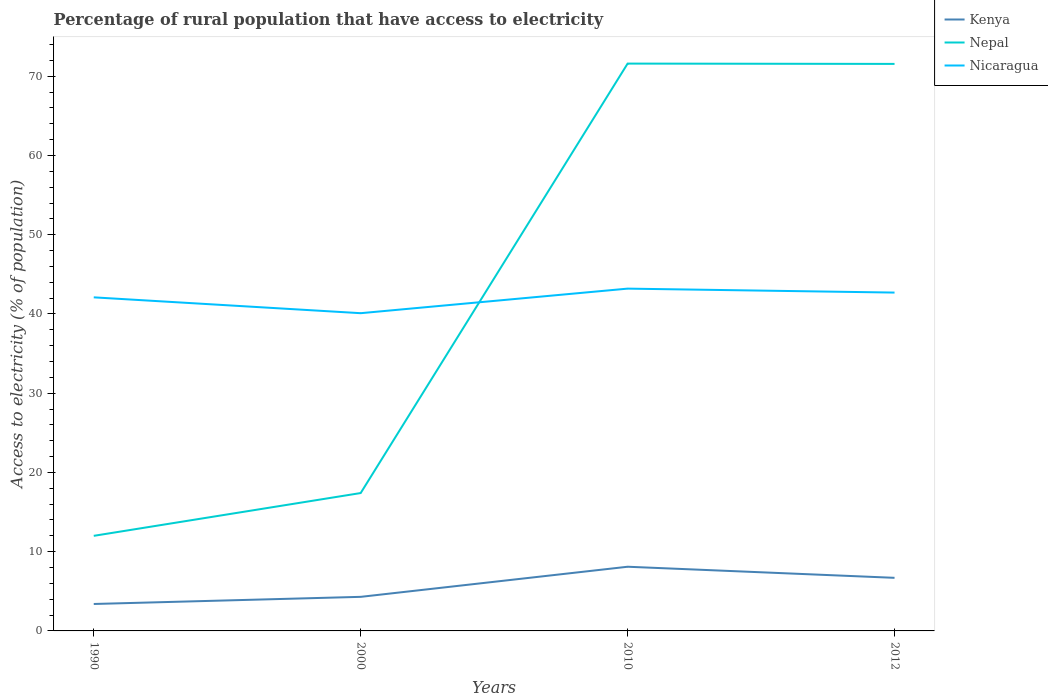Is the number of lines equal to the number of legend labels?
Offer a terse response. Yes. What is the total percentage of rural population that have access to electricity in Nicaragua in the graph?
Ensure brevity in your answer.  -1.1. What is the difference between the highest and the second highest percentage of rural population that have access to electricity in Kenya?
Offer a very short reply. 4.7. Are the values on the major ticks of Y-axis written in scientific E-notation?
Ensure brevity in your answer.  No. Does the graph contain any zero values?
Keep it short and to the point. No. Where does the legend appear in the graph?
Make the answer very short. Top right. What is the title of the graph?
Offer a terse response. Percentage of rural population that have access to electricity. What is the label or title of the Y-axis?
Your answer should be very brief. Access to electricity (% of population). What is the Access to electricity (% of population) of Kenya in 1990?
Your response must be concise. 3.4. What is the Access to electricity (% of population) in Nepal in 1990?
Your response must be concise. 12. What is the Access to electricity (% of population) of Nicaragua in 1990?
Keep it short and to the point. 42.1. What is the Access to electricity (% of population) in Nicaragua in 2000?
Make the answer very short. 40.1. What is the Access to electricity (% of population) of Kenya in 2010?
Your answer should be very brief. 8.1. What is the Access to electricity (% of population) in Nepal in 2010?
Give a very brief answer. 71.6. What is the Access to electricity (% of population) of Nicaragua in 2010?
Ensure brevity in your answer.  43.2. What is the Access to electricity (% of population) of Kenya in 2012?
Give a very brief answer. 6.7. What is the Access to electricity (% of population) of Nepal in 2012?
Ensure brevity in your answer.  71.56. What is the Access to electricity (% of population) of Nicaragua in 2012?
Ensure brevity in your answer.  42.7. Across all years, what is the maximum Access to electricity (% of population) in Kenya?
Offer a very short reply. 8.1. Across all years, what is the maximum Access to electricity (% of population) of Nepal?
Give a very brief answer. 71.6. Across all years, what is the maximum Access to electricity (% of population) in Nicaragua?
Offer a terse response. 43.2. Across all years, what is the minimum Access to electricity (% of population) in Kenya?
Keep it short and to the point. 3.4. Across all years, what is the minimum Access to electricity (% of population) of Nepal?
Make the answer very short. 12. Across all years, what is the minimum Access to electricity (% of population) in Nicaragua?
Ensure brevity in your answer.  40.1. What is the total Access to electricity (% of population) in Nepal in the graph?
Give a very brief answer. 172.56. What is the total Access to electricity (% of population) in Nicaragua in the graph?
Your response must be concise. 168.1. What is the difference between the Access to electricity (% of population) in Nepal in 1990 and that in 2000?
Offer a very short reply. -5.4. What is the difference between the Access to electricity (% of population) of Nicaragua in 1990 and that in 2000?
Your response must be concise. 2. What is the difference between the Access to electricity (% of population) in Kenya in 1990 and that in 2010?
Provide a succinct answer. -4.7. What is the difference between the Access to electricity (% of population) of Nepal in 1990 and that in 2010?
Offer a terse response. -59.6. What is the difference between the Access to electricity (% of population) of Nepal in 1990 and that in 2012?
Keep it short and to the point. -59.56. What is the difference between the Access to electricity (% of population) of Nicaragua in 1990 and that in 2012?
Offer a very short reply. -0.6. What is the difference between the Access to electricity (% of population) in Kenya in 2000 and that in 2010?
Give a very brief answer. -3.8. What is the difference between the Access to electricity (% of population) in Nepal in 2000 and that in 2010?
Make the answer very short. -54.2. What is the difference between the Access to electricity (% of population) of Kenya in 2000 and that in 2012?
Keep it short and to the point. -2.4. What is the difference between the Access to electricity (% of population) of Nepal in 2000 and that in 2012?
Offer a very short reply. -54.16. What is the difference between the Access to electricity (% of population) of Nicaragua in 2010 and that in 2012?
Give a very brief answer. 0.5. What is the difference between the Access to electricity (% of population) of Kenya in 1990 and the Access to electricity (% of population) of Nicaragua in 2000?
Provide a short and direct response. -36.7. What is the difference between the Access to electricity (% of population) in Nepal in 1990 and the Access to electricity (% of population) in Nicaragua in 2000?
Provide a short and direct response. -28.1. What is the difference between the Access to electricity (% of population) of Kenya in 1990 and the Access to electricity (% of population) of Nepal in 2010?
Offer a very short reply. -68.2. What is the difference between the Access to electricity (% of population) in Kenya in 1990 and the Access to electricity (% of population) in Nicaragua in 2010?
Provide a short and direct response. -39.8. What is the difference between the Access to electricity (% of population) of Nepal in 1990 and the Access to electricity (% of population) of Nicaragua in 2010?
Keep it short and to the point. -31.2. What is the difference between the Access to electricity (% of population) of Kenya in 1990 and the Access to electricity (% of population) of Nepal in 2012?
Your answer should be compact. -68.16. What is the difference between the Access to electricity (% of population) in Kenya in 1990 and the Access to electricity (% of population) in Nicaragua in 2012?
Your answer should be compact. -39.3. What is the difference between the Access to electricity (% of population) of Nepal in 1990 and the Access to electricity (% of population) of Nicaragua in 2012?
Make the answer very short. -30.7. What is the difference between the Access to electricity (% of population) in Kenya in 2000 and the Access to electricity (% of population) in Nepal in 2010?
Make the answer very short. -67.3. What is the difference between the Access to electricity (% of population) in Kenya in 2000 and the Access to electricity (% of population) in Nicaragua in 2010?
Your response must be concise. -38.9. What is the difference between the Access to electricity (% of population) of Nepal in 2000 and the Access to electricity (% of population) of Nicaragua in 2010?
Provide a succinct answer. -25.8. What is the difference between the Access to electricity (% of population) in Kenya in 2000 and the Access to electricity (% of population) in Nepal in 2012?
Your response must be concise. -67.26. What is the difference between the Access to electricity (% of population) in Kenya in 2000 and the Access to electricity (% of population) in Nicaragua in 2012?
Your response must be concise. -38.4. What is the difference between the Access to electricity (% of population) in Nepal in 2000 and the Access to electricity (% of population) in Nicaragua in 2012?
Your response must be concise. -25.3. What is the difference between the Access to electricity (% of population) in Kenya in 2010 and the Access to electricity (% of population) in Nepal in 2012?
Your answer should be compact. -63.46. What is the difference between the Access to electricity (% of population) of Kenya in 2010 and the Access to electricity (% of population) of Nicaragua in 2012?
Give a very brief answer. -34.6. What is the difference between the Access to electricity (% of population) in Nepal in 2010 and the Access to electricity (% of population) in Nicaragua in 2012?
Offer a very short reply. 28.9. What is the average Access to electricity (% of population) in Kenya per year?
Provide a short and direct response. 5.62. What is the average Access to electricity (% of population) of Nepal per year?
Your answer should be very brief. 43.14. What is the average Access to electricity (% of population) in Nicaragua per year?
Keep it short and to the point. 42.02. In the year 1990, what is the difference between the Access to electricity (% of population) in Kenya and Access to electricity (% of population) in Nicaragua?
Your answer should be compact. -38.7. In the year 1990, what is the difference between the Access to electricity (% of population) of Nepal and Access to electricity (% of population) of Nicaragua?
Offer a terse response. -30.1. In the year 2000, what is the difference between the Access to electricity (% of population) in Kenya and Access to electricity (% of population) in Nicaragua?
Keep it short and to the point. -35.8. In the year 2000, what is the difference between the Access to electricity (% of population) in Nepal and Access to electricity (% of population) in Nicaragua?
Offer a very short reply. -22.7. In the year 2010, what is the difference between the Access to electricity (% of population) in Kenya and Access to electricity (% of population) in Nepal?
Provide a succinct answer. -63.5. In the year 2010, what is the difference between the Access to electricity (% of population) of Kenya and Access to electricity (% of population) of Nicaragua?
Offer a terse response. -35.1. In the year 2010, what is the difference between the Access to electricity (% of population) in Nepal and Access to electricity (% of population) in Nicaragua?
Give a very brief answer. 28.4. In the year 2012, what is the difference between the Access to electricity (% of population) of Kenya and Access to electricity (% of population) of Nepal?
Your answer should be compact. -64.86. In the year 2012, what is the difference between the Access to electricity (% of population) in Kenya and Access to electricity (% of population) in Nicaragua?
Keep it short and to the point. -36. In the year 2012, what is the difference between the Access to electricity (% of population) in Nepal and Access to electricity (% of population) in Nicaragua?
Keep it short and to the point. 28.86. What is the ratio of the Access to electricity (% of population) in Kenya in 1990 to that in 2000?
Your answer should be compact. 0.79. What is the ratio of the Access to electricity (% of population) in Nepal in 1990 to that in 2000?
Ensure brevity in your answer.  0.69. What is the ratio of the Access to electricity (% of population) of Nicaragua in 1990 to that in 2000?
Keep it short and to the point. 1.05. What is the ratio of the Access to electricity (% of population) of Kenya in 1990 to that in 2010?
Keep it short and to the point. 0.42. What is the ratio of the Access to electricity (% of population) of Nepal in 1990 to that in 2010?
Your answer should be compact. 0.17. What is the ratio of the Access to electricity (% of population) in Nicaragua in 1990 to that in 2010?
Your response must be concise. 0.97. What is the ratio of the Access to electricity (% of population) in Kenya in 1990 to that in 2012?
Your answer should be very brief. 0.51. What is the ratio of the Access to electricity (% of population) in Nepal in 1990 to that in 2012?
Give a very brief answer. 0.17. What is the ratio of the Access to electricity (% of population) in Nicaragua in 1990 to that in 2012?
Provide a short and direct response. 0.99. What is the ratio of the Access to electricity (% of population) of Kenya in 2000 to that in 2010?
Give a very brief answer. 0.53. What is the ratio of the Access to electricity (% of population) in Nepal in 2000 to that in 2010?
Offer a terse response. 0.24. What is the ratio of the Access to electricity (% of population) in Nicaragua in 2000 to that in 2010?
Provide a short and direct response. 0.93. What is the ratio of the Access to electricity (% of population) in Kenya in 2000 to that in 2012?
Your answer should be compact. 0.64. What is the ratio of the Access to electricity (% of population) in Nepal in 2000 to that in 2012?
Offer a very short reply. 0.24. What is the ratio of the Access to electricity (% of population) in Nicaragua in 2000 to that in 2012?
Your answer should be very brief. 0.94. What is the ratio of the Access to electricity (% of population) of Kenya in 2010 to that in 2012?
Offer a terse response. 1.21. What is the ratio of the Access to electricity (% of population) of Nicaragua in 2010 to that in 2012?
Offer a terse response. 1.01. What is the difference between the highest and the lowest Access to electricity (% of population) in Kenya?
Make the answer very short. 4.7. What is the difference between the highest and the lowest Access to electricity (% of population) of Nepal?
Offer a terse response. 59.6. 